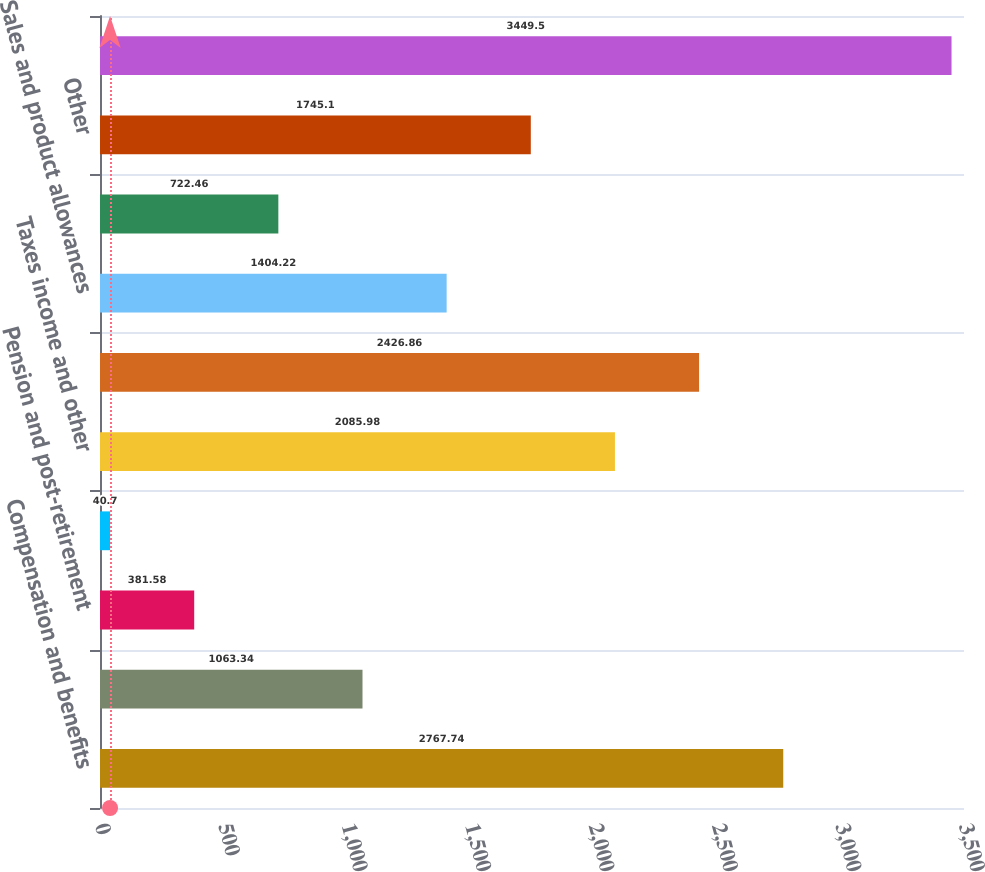Convert chart. <chart><loc_0><loc_0><loc_500><loc_500><bar_chart><fcel>Compensation and benefits<fcel>Claims including<fcel>Pension and post-retirement<fcel>Environmental and regulatory<fcel>Taxes income and other<fcel>Deferred revenue<fcel>Sales and product allowances<fcel>Warranty<fcel>Other<fcel>Total<nl><fcel>2767.74<fcel>1063.34<fcel>381.58<fcel>40.7<fcel>2085.98<fcel>2426.86<fcel>1404.22<fcel>722.46<fcel>1745.1<fcel>3449.5<nl></chart> 